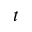Convert formula to latex. <formula><loc_0><loc_0><loc_500><loc_500>t</formula> 